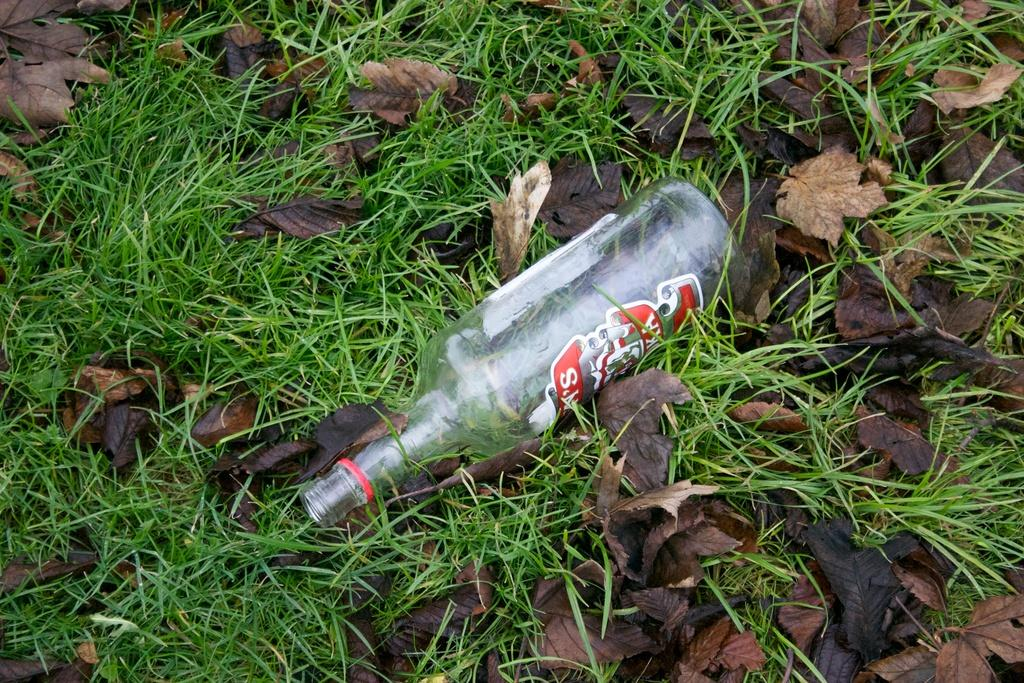What object can be seen in the image that is typically used for holding water? There is a water bottle in the image. Where is the water bottle located? The water bottle is lying on grass. What type of natural material is present in the image? There are dry leaves in the image. What type of goat can be seen grazing on the grass in the image? There is no goat present in the image; it only features a water bottle lying on grass and dry leaves. What date is marked on the calendar in the image? There is no calendar present in the image. 